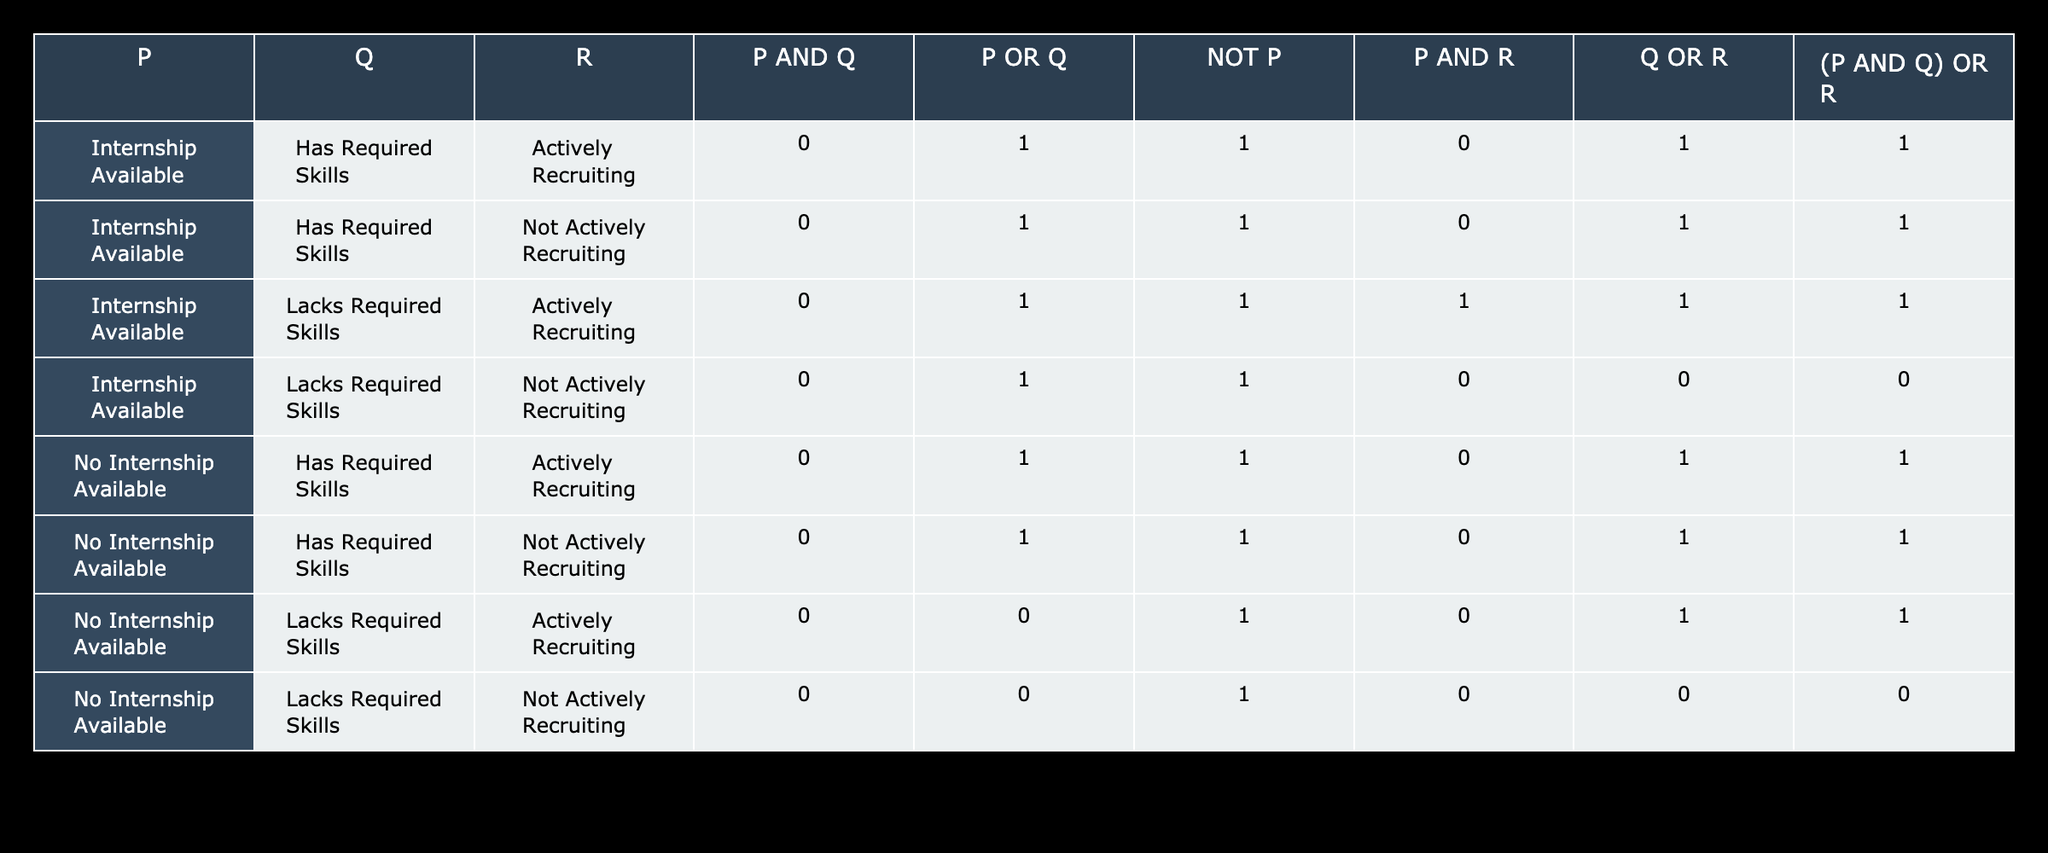What is the value of P AND Q when the internship is available and the skills required are present? In the table, the entry for "Internship Available" and "Has Required Skills" shows that the value for P AND Q is 0.
Answer: 0 What is the value of Q OR R when the internship is not available and skills are lacking? Looking at the row for "No Internship Available" and "Lacks Required Skills" with "Not Actively Recruiting", the value for Q OR R is 0.
Answer: 0 How many combinations result in 1 for P OR Q? By counting the rows where the value for P OR Q is 1, we find there are 6 such combinations: all rows except the last two.
Answer: 6 Is there a case where there is an internship available and the company is actively recruiting, but lacks required skills? Checking the entries, there is one case "Internship Available", "Lacks Required Skills", "Actively Recruiting", which shows it does exist.
Answer: Yes What is the sum of the values for (P AND Q) OR R across all scenarios? We first need to evaluate (P AND Q) OR R for each row. The values found are 1, 1, 1, 0, 1, 1, 1, 0. The sum is (1+1+1+0+1+1+1+0) = 6.
Answer: 6 Are there any scenarios where internships are available and the required skills are lacking, yet recruiting is not active? Reviewing the table, we find one scenario: "Internship Available", "Lacks Required Skills", "Not Actively Recruiting". It confirms the presence of such a case.
Answer: Yes What is the relationship between P AND R when tasks meet all conditions? Analyzing the entry with "Internship Available", "Has Required Skills", "Actively Recruiting", the value for P AND R is 0, indicating that no positive relationship exists in that scenario.
Answer: 0 What is the average of the P AND R values across all entries? Evaluating P AND R across all rows yields the values: 0, 0, 1, 0, 0, 0, 0, 0. The average is (0+0+1+0+0+0+0+0)/8 = 1/8 = 0.125.
Answer: 0.125 Is it true that having required skills guarantees that the internship is available? Checking the rows where "Has Required Skills" appears, we see both "Internship Available" and "No Internship Available" cases. Thus, the statement is false.
Answer: No 